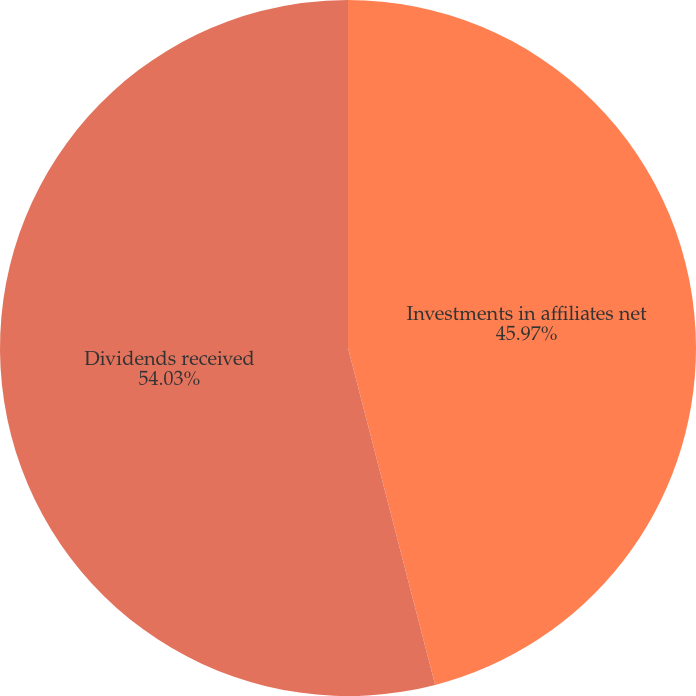Convert chart to OTSL. <chart><loc_0><loc_0><loc_500><loc_500><pie_chart><fcel>Investments in affiliates net<fcel>Dividends received<nl><fcel>45.97%<fcel>54.03%<nl></chart> 